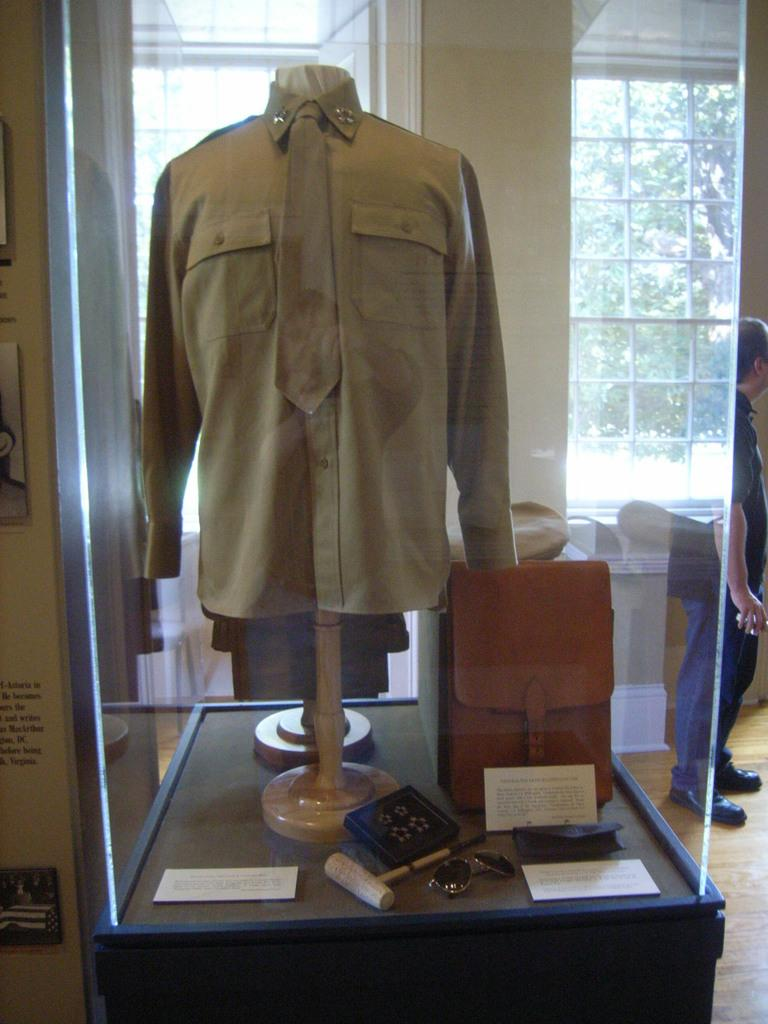What type of clothing item is in the image? There is a shirt in the image. What else can be seen in the image besides the shirt? There is a bag in the image. What is the context of the image, considering the presence of articles used by a person? The image features a man standing, which suggests that the articles are being used by him. What can be seen through the window in the image? There are trees visible through the window in the image. What type of creature is pushing the man in the image? There is no creature present in the image, and the man is not being pushed. What is the man using to cover himself in the image? The man is not using a quilt or any other covering in the image. 